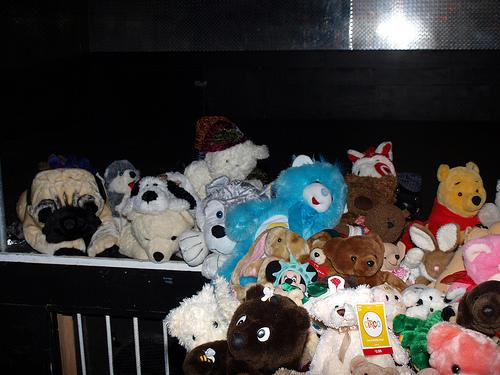Question: what animal are most of these toys?
Choices:
A. Bears.
B. Dogs.
C. Cats.
D. Horses.
Answer with the letter. Answer: A Question: where is the blue bear?
Choices:
A. In the middle.
B. On the right.
C. On the left.
D. At the top of the bunch.
Answer with the letter. Answer: A Question: who plays with stuffed animals?
Choices:
A. Boys.
B. Children.
C. Girls.
D. Babies.
Answer with the letter. Answer: B Question: what is in the middle of the animal faces?
Choices:
A. Whiskers.
B. A red spot.
C. Nose.
D. A snout.
Answer with the letter. Answer: C 